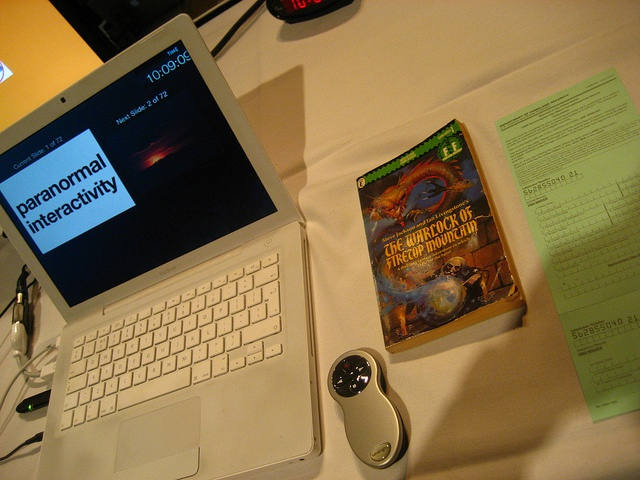Describe the objects in this image and their specific colors. I can see laptop in orange, black, tan, and olive tones, book in orange, maroon, black, and olive tones, remote in orange, black, olive, and tan tones, and clock in orange, black, maroon, red, and brown tones in this image. 